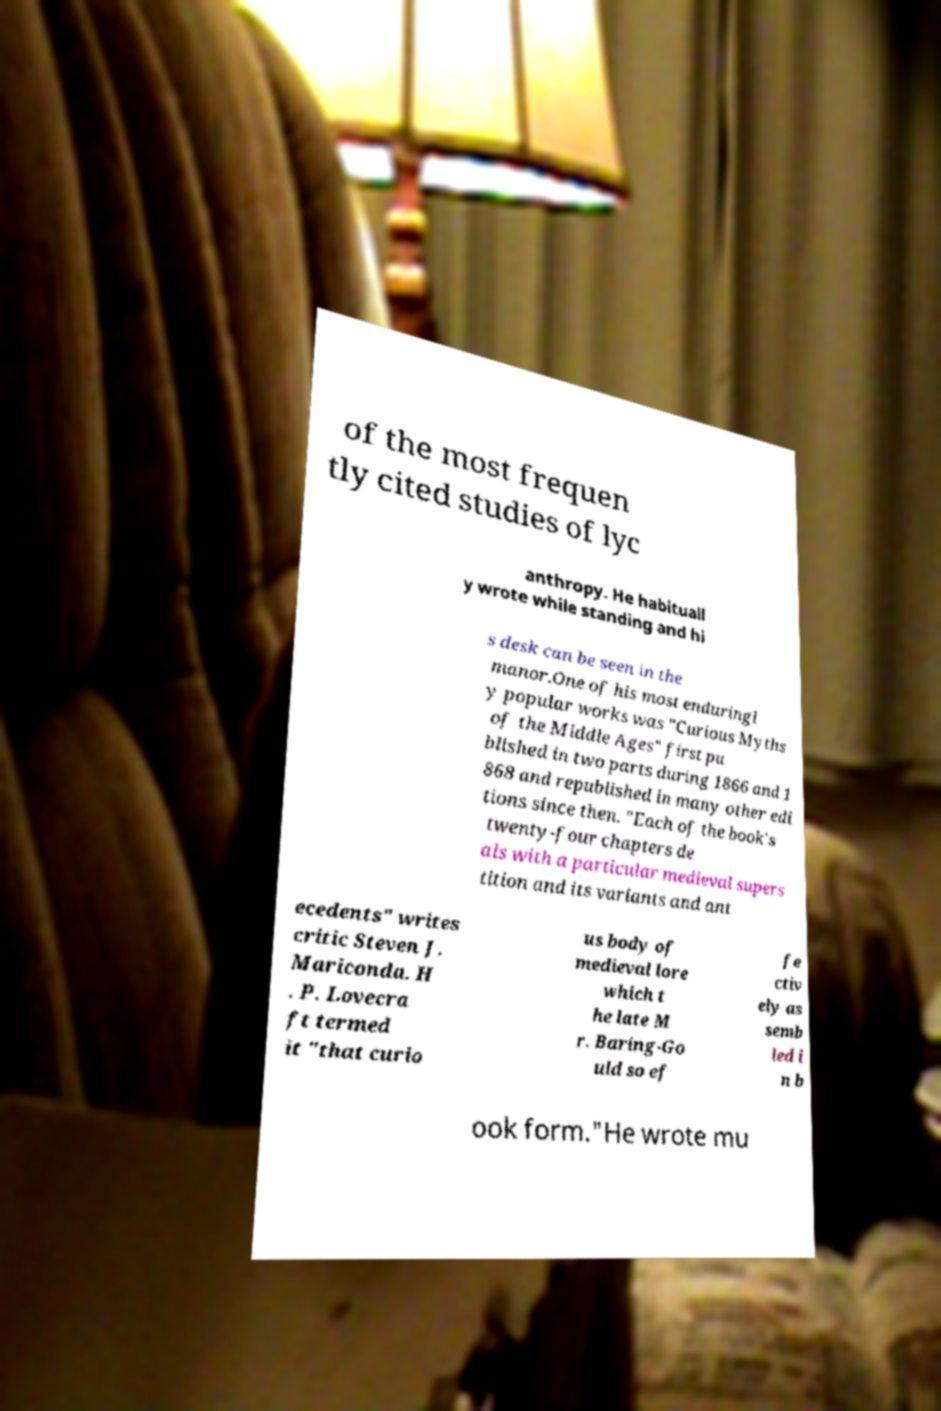For documentation purposes, I need the text within this image transcribed. Could you provide that? of the most frequen tly cited studies of lyc anthropy. He habituall y wrote while standing and hi s desk can be seen in the manor.One of his most enduringl y popular works was "Curious Myths of the Middle Ages" first pu blished in two parts during 1866 and 1 868 and republished in many other edi tions since then. "Each of the book's twenty-four chapters de als with a particular medieval supers tition and its variants and ant ecedents" writes critic Steven J. Mariconda. H . P. Lovecra ft termed it "that curio us body of medieval lore which t he late M r. Baring-Go uld so ef fe ctiv ely as semb led i n b ook form."He wrote mu 